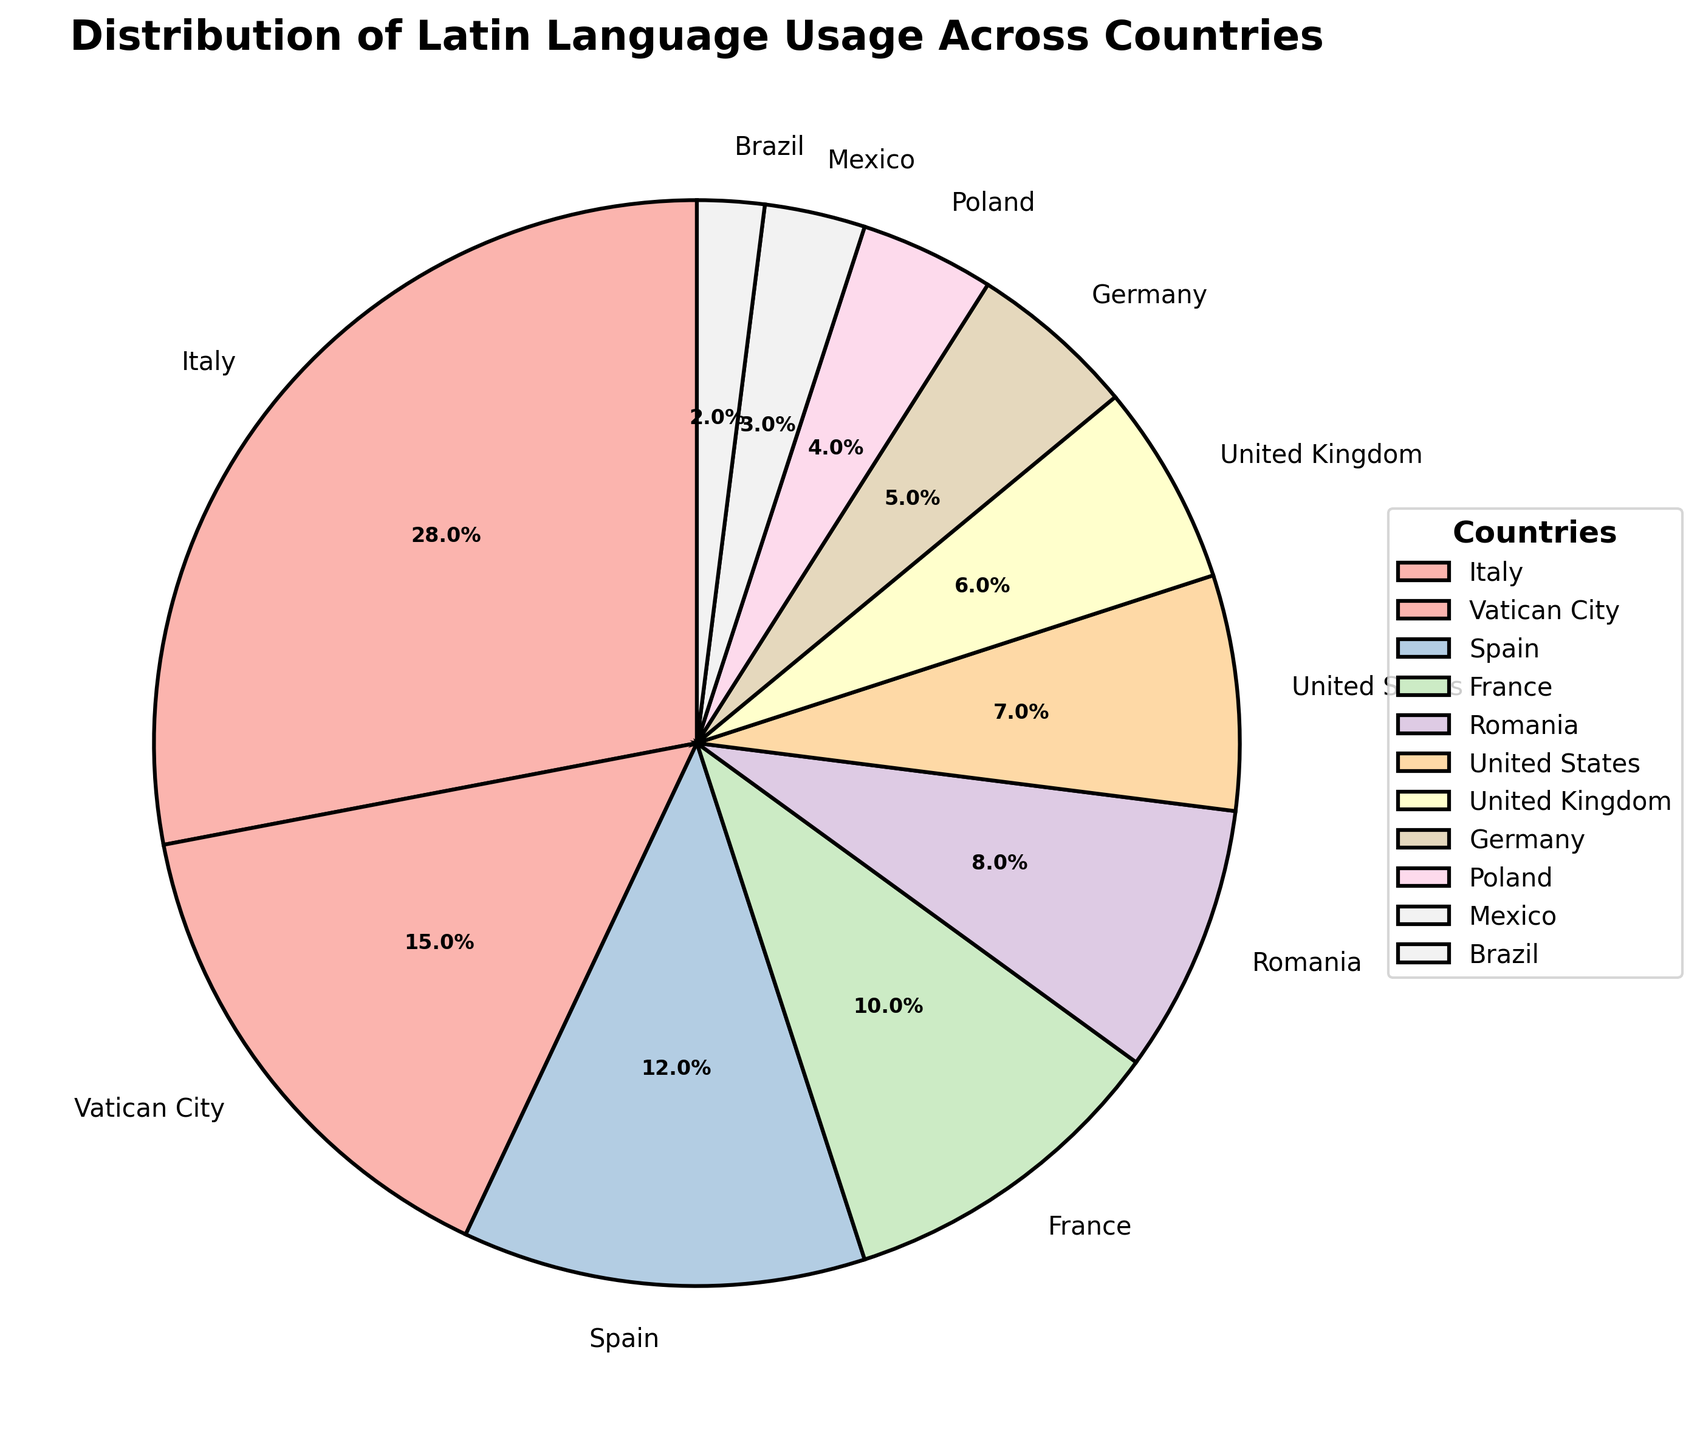What percentage of Latin language usage is covered by Italy and Vatican City combined? Add Italy's percentage (28%) to Vatican City's percentage (15%) to get the combined percentage. 28 + 15 = 43
Answer: 43 Which country has the lowest percentage of Latin language usage? By looking at the figures, Brazil has the lowest percentage at 2%.
Answer: Brazil What is the difference in Latin language usage percentage between Italy and Spain? Subtract Spain's percentage (12%) from Italy's percentage (28%). 28 - 12 = 16
Answer: 16 Which countries contribute more than 10% to Latin language usage? Italy (28%), Vatican City (15%), Spain (12%), and France (10%) all contribute more than 10%.
Answer: Italy, Vatican City, Spain Does Vatican City or the United States contribute more to Latin language usage? By how much? Compare Vatican City's 15% and the United States' 7%. 15 - 7 = 8. Vatican City contributes 8% more.
Answer: Vatican City by 8 What is the total percentage of Latin language usage from the United Kingdom, Germany, Poland, Mexico, and Brazil? Sum the percentages: 6% (UK) + 5% (Germany) + 4% (Poland) + 3% (Mexico) + 2% (Brazil) = 20%
Answer: 20 By viewing the chart, which countries are visually represented using paler shades of color? Colors generally follow the order of percentage. United States (7%), United Kingdom (6%), Germany (5%), Poland (4%), Mexico (3%), and Brazil (2%) have paler shades compared to higher percentage countries.
Answer: United States, United Kingdom, Germany, Poland, Mexico, Brazil Is the Latin language usage in France closer to the usage in Spain or Romania? Compare France's 10% to Spain's 12% and Romania's 8%. The difference from Spain is 2% (12-10), and from Romania is 2% (10-8), making it equally close.
Answer: Equally close to both How much more is Italy's percentage compared to the next highest country? Italy is 28%, and the next highest is Vatican City at 15%. 28 - 15 = 13. Italy's usage is 13% more.
Answer: 13 